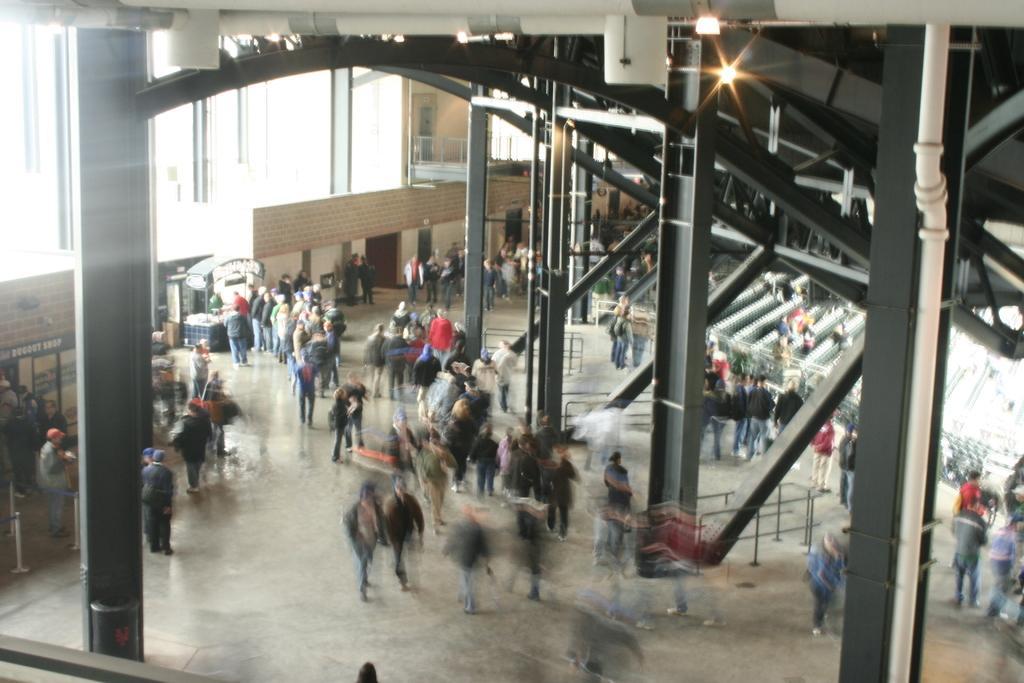Describe this image in one or two sentences. In this picture, we see people are walking. On either side of the picture, we see pillars. Behind that, there are many pillars and lights. On the left side, we see a wall and windows. At the top, we see the roof of the building. 